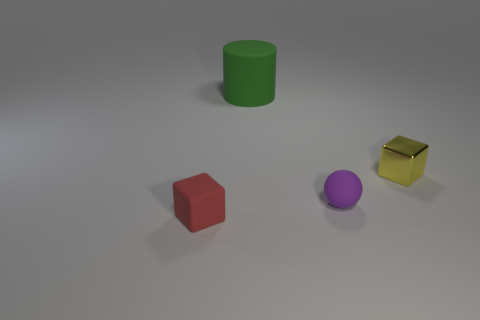Add 3 cylinders. How many objects exist? 7 Subtract all spheres. How many objects are left? 3 Add 1 large purple spheres. How many large purple spheres exist? 1 Subtract 1 purple balls. How many objects are left? 3 Subtract all large purple things. Subtract all small red objects. How many objects are left? 3 Add 1 small balls. How many small balls are left? 2 